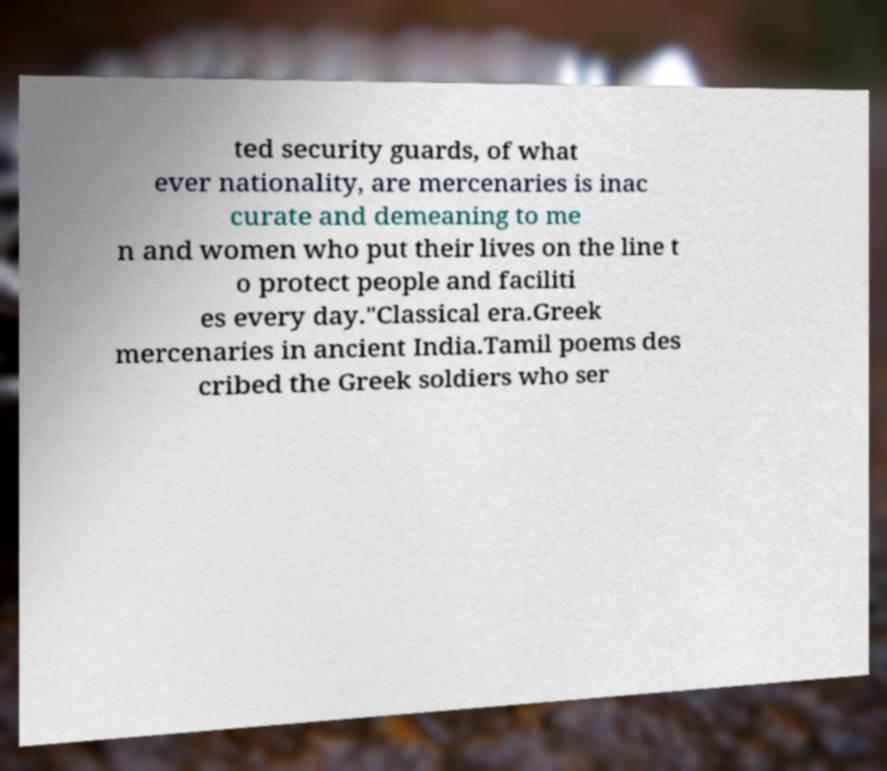For documentation purposes, I need the text within this image transcribed. Could you provide that? ted security guards, of what ever nationality, are mercenaries is inac curate and demeaning to me n and women who put their lives on the line t o protect people and faciliti es every day."Classical era.Greek mercenaries in ancient India.Tamil poems des cribed the Greek soldiers who ser 